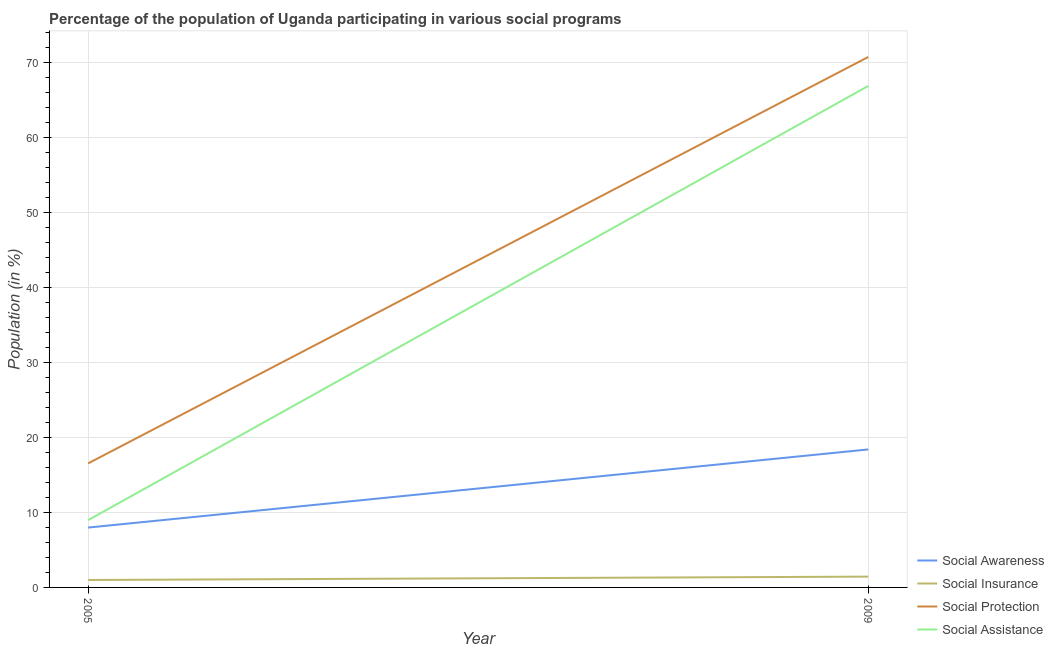How many different coloured lines are there?
Your response must be concise. 4. Is the number of lines equal to the number of legend labels?
Offer a very short reply. Yes. What is the participation of population in social insurance programs in 2009?
Provide a short and direct response. 1.44. Across all years, what is the maximum participation of population in social insurance programs?
Your answer should be very brief. 1.44. Across all years, what is the minimum participation of population in social assistance programs?
Ensure brevity in your answer.  8.97. In which year was the participation of population in social assistance programs minimum?
Give a very brief answer. 2005. What is the total participation of population in social insurance programs in the graph?
Offer a very short reply. 2.43. What is the difference between the participation of population in social assistance programs in 2005 and that in 2009?
Your response must be concise. -57.86. What is the difference between the participation of population in social protection programs in 2009 and the participation of population in social awareness programs in 2005?
Offer a terse response. 62.71. What is the average participation of population in social insurance programs per year?
Your response must be concise. 1.21. In the year 2009, what is the difference between the participation of population in social protection programs and participation of population in social awareness programs?
Your answer should be compact. 52.3. What is the ratio of the participation of population in social protection programs in 2005 to that in 2009?
Give a very brief answer. 0.23. Is the participation of population in social insurance programs in 2005 less than that in 2009?
Offer a terse response. Yes. Is it the case that in every year, the sum of the participation of population in social insurance programs and participation of population in social assistance programs is greater than the sum of participation of population in social protection programs and participation of population in social awareness programs?
Offer a very short reply. No. Is it the case that in every year, the sum of the participation of population in social awareness programs and participation of population in social insurance programs is greater than the participation of population in social protection programs?
Your response must be concise. No. Does the participation of population in social protection programs monotonically increase over the years?
Make the answer very short. Yes. Is the participation of population in social insurance programs strictly greater than the participation of population in social assistance programs over the years?
Your answer should be compact. No. Is the participation of population in social insurance programs strictly less than the participation of population in social awareness programs over the years?
Your answer should be compact. Yes. How many years are there in the graph?
Your answer should be very brief. 2. Are the values on the major ticks of Y-axis written in scientific E-notation?
Ensure brevity in your answer.  No. Does the graph contain any zero values?
Provide a short and direct response. No. Does the graph contain grids?
Ensure brevity in your answer.  Yes. Where does the legend appear in the graph?
Make the answer very short. Bottom right. What is the title of the graph?
Keep it short and to the point. Percentage of the population of Uganda participating in various social programs . Does "Fourth 20% of population" appear as one of the legend labels in the graph?
Provide a short and direct response. No. What is the label or title of the X-axis?
Offer a very short reply. Year. What is the label or title of the Y-axis?
Provide a short and direct response. Population (in %). What is the Population (in %) in Social Awareness in 2005?
Your answer should be compact. 7.98. What is the Population (in %) in Social Insurance in 2005?
Provide a succinct answer. 0.99. What is the Population (in %) in Social Protection in 2005?
Your answer should be compact. 16.53. What is the Population (in %) in Social Assistance in 2005?
Make the answer very short. 8.97. What is the Population (in %) of Social Awareness in 2009?
Your response must be concise. 18.39. What is the Population (in %) of Social Insurance in 2009?
Offer a terse response. 1.44. What is the Population (in %) of Social Protection in 2009?
Keep it short and to the point. 70.69. What is the Population (in %) in Social Assistance in 2009?
Make the answer very short. 66.83. Across all years, what is the maximum Population (in %) in Social Awareness?
Give a very brief answer. 18.39. Across all years, what is the maximum Population (in %) of Social Insurance?
Give a very brief answer. 1.44. Across all years, what is the maximum Population (in %) of Social Protection?
Give a very brief answer. 70.69. Across all years, what is the maximum Population (in %) of Social Assistance?
Your answer should be compact. 66.83. Across all years, what is the minimum Population (in %) of Social Awareness?
Offer a very short reply. 7.98. Across all years, what is the minimum Population (in %) in Social Insurance?
Your answer should be very brief. 0.99. Across all years, what is the minimum Population (in %) of Social Protection?
Offer a very short reply. 16.53. Across all years, what is the minimum Population (in %) in Social Assistance?
Keep it short and to the point. 8.97. What is the total Population (in %) of Social Awareness in the graph?
Your response must be concise. 26.36. What is the total Population (in %) of Social Insurance in the graph?
Ensure brevity in your answer.  2.43. What is the total Population (in %) of Social Protection in the graph?
Provide a short and direct response. 87.22. What is the total Population (in %) in Social Assistance in the graph?
Your response must be concise. 75.8. What is the difference between the Population (in %) in Social Awareness in 2005 and that in 2009?
Give a very brief answer. -10.41. What is the difference between the Population (in %) in Social Insurance in 2005 and that in 2009?
Offer a very short reply. -0.45. What is the difference between the Population (in %) in Social Protection in 2005 and that in 2009?
Your answer should be very brief. -54.16. What is the difference between the Population (in %) of Social Assistance in 2005 and that in 2009?
Your answer should be compact. -57.86. What is the difference between the Population (in %) in Social Awareness in 2005 and the Population (in %) in Social Insurance in 2009?
Give a very brief answer. 6.54. What is the difference between the Population (in %) in Social Awareness in 2005 and the Population (in %) in Social Protection in 2009?
Provide a short and direct response. -62.71. What is the difference between the Population (in %) in Social Awareness in 2005 and the Population (in %) in Social Assistance in 2009?
Keep it short and to the point. -58.85. What is the difference between the Population (in %) of Social Insurance in 2005 and the Population (in %) of Social Protection in 2009?
Give a very brief answer. -69.7. What is the difference between the Population (in %) of Social Insurance in 2005 and the Population (in %) of Social Assistance in 2009?
Your response must be concise. -65.84. What is the difference between the Population (in %) in Social Protection in 2005 and the Population (in %) in Social Assistance in 2009?
Your response must be concise. -50.3. What is the average Population (in %) of Social Awareness per year?
Offer a very short reply. 13.18. What is the average Population (in %) in Social Insurance per year?
Provide a short and direct response. 1.21. What is the average Population (in %) in Social Protection per year?
Keep it short and to the point. 43.61. What is the average Population (in %) of Social Assistance per year?
Make the answer very short. 37.9. In the year 2005, what is the difference between the Population (in %) in Social Awareness and Population (in %) in Social Insurance?
Give a very brief answer. 6.99. In the year 2005, what is the difference between the Population (in %) in Social Awareness and Population (in %) in Social Protection?
Make the answer very short. -8.55. In the year 2005, what is the difference between the Population (in %) in Social Awareness and Population (in %) in Social Assistance?
Provide a short and direct response. -0.99. In the year 2005, what is the difference between the Population (in %) in Social Insurance and Population (in %) in Social Protection?
Make the answer very short. -15.54. In the year 2005, what is the difference between the Population (in %) of Social Insurance and Population (in %) of Social Assistance?
Your answer should be compact. -7.98. In the year 2005, what is the difference between the Population (in %) in Social Protection and Population (in %) in Social Assistance?
Offer a very short reply. 7.56. In the year 2009, what is the difference between the Population (in %) of Social Awareness and Population (in %) of Social Insurance?
Make the answer very short. 16.95. In the year 2009, what is the difference between the Population (in %) of Social Awareness and Population (in %) of Social Protection?
Ensure brevity in your answer.  -52.3. In the year 2009, what is the difference between the Population (in %) of Social Awareness and Population (in %) of Social Assistance?
Your answer should be compact. -48.44. In the year 2009, what is the difference between the Population (in %) in Social Insurance and Population (in %) in Social Protection?
Make the answer very short. -69.25. In the year 2009, what is the difference between the Population (in %) of Social Insurance and Population (in %) of Social Assistance?
Your response must be concise. -65.39. In the year 2009, what is the difference between the Population (in %) in Social Protection and Population (in %) in Social Assistance?
Offer a terse response. 3.86. What is the ratio of the Population (in %) of Social Awareness in 2005 to that in 2009?
Provide a succinct answer. 0.43. What is the ratio of the Population (in %) of Social Insurance in 2005 to that in 2009?
Ensure brevity in your answer.  0.69. What is the ratio of the Population (in %) of Social Protection in 2005 to that in 2009?
Offer a terse response. 0.23. What is the ratio of the Population (in %) of Social Assistance in 2005 to that in 2009?
Keep it short and to the point. 0.13. What is the difference between the highest and the second highest Population (in %) in Social Awareness?
Offer a terse response. 10.41. What is the difference between the highest and the second highest Population (in %) of Social Insurance?
Give a very brief answer. 0.45. What is the difference between the highest and the second highest Population (in %) of Social Protection?
Ensure brevity in your answer.  54.16. What is the difference between the highest and the second highest Population (in %) in Social Assistance?
Keep it short and to the point. 57.86. What is the difference between the highest and the lowest Population (in %) of Social Awareness?
Your answer should be compact. 10.41. What is the difference between the highest and the lowest Population (in %) in Social Insurance?
Your answer should be very brief. 0.45. What is the difference between the highest and the lowest Population (in %) of Social Protection?
Offer a terse response. 54.16. What is the difference between the highest and the lowest Population (in %) of Social Assistance?
Your response must be concise. 57.86. 